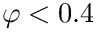Convert formula to latex. <formula><loc_0><loc_0><loc_500><loc_500>\varphi < 0 . 4</formula> 